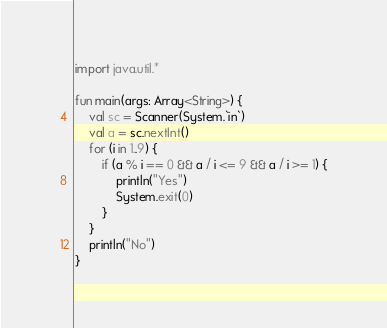<code> <loc_0><loc_0><loc_500><loc_500><_Kotlin_>import java.util.*

fun main(args: Array<String>) {
    val sc = Scanner(System.`in`)
    val a = sc.nextInt()
    for (i in 1..9) {
        if (a % i == 0 && a / i <= 9 && a / i >= 1) {
            println("Yes")
            System.exit(0)
        }
    }
    println("No")
}</code> 